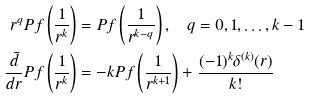Convert formula to latex. <formula><loc_0><loc_0><loc_500><loc_500>r ^ { q } P f \left ( \frac { 1 } { r ^ { k } } \right ) & = P f \left ( \frac { 1 } { r ^ { k - q } } \right ) , \quad q = 0 , 1 , \dots , k - 1 \\ \ \frac { \bar { d } } { d r } P f \left ( \frac { 1 } { r ^ { k } } \right ) & = - k P f \left ( \frac { 1 } { r ^ { k + 1 } } \right ) + \frac { ( - 1 ) ^ { k } \delta ^ { ( k ) } ( r ) } { k ! }</formula> 